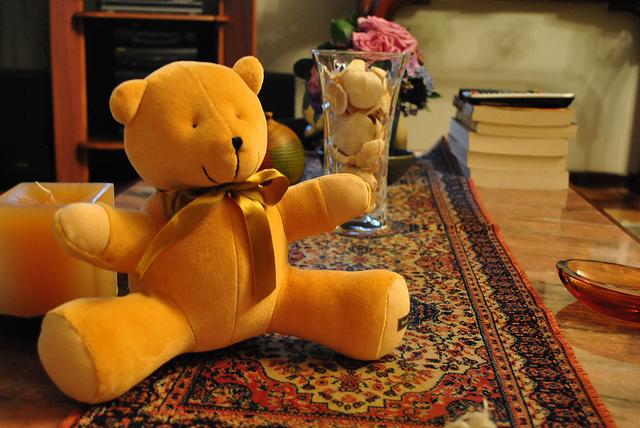What is the table runner designed to look like?
Short answer required. Carpet. What color is the ribbon around the bear's neck?
Answer briefly. Gold. What is placed on top of the stack of books?
Be succinct. Remote. Is this an old teddy bear?
Write a very short answer. No. 